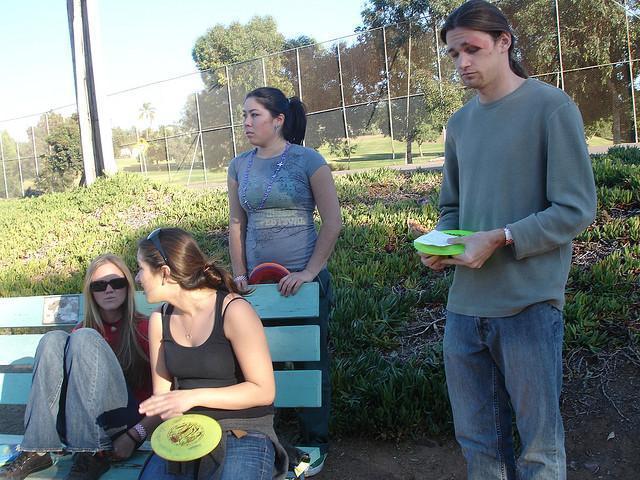How many people are there?
Give a very brief answer. 4. 